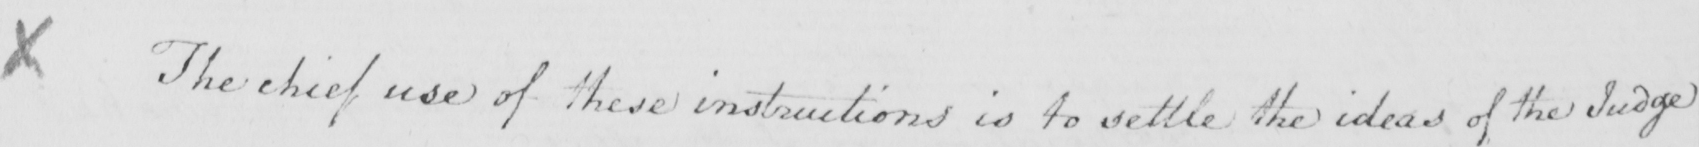Please transcribe the handwritten text in this image. X The chief use of these instructions is to settle the ideas of the Judge 